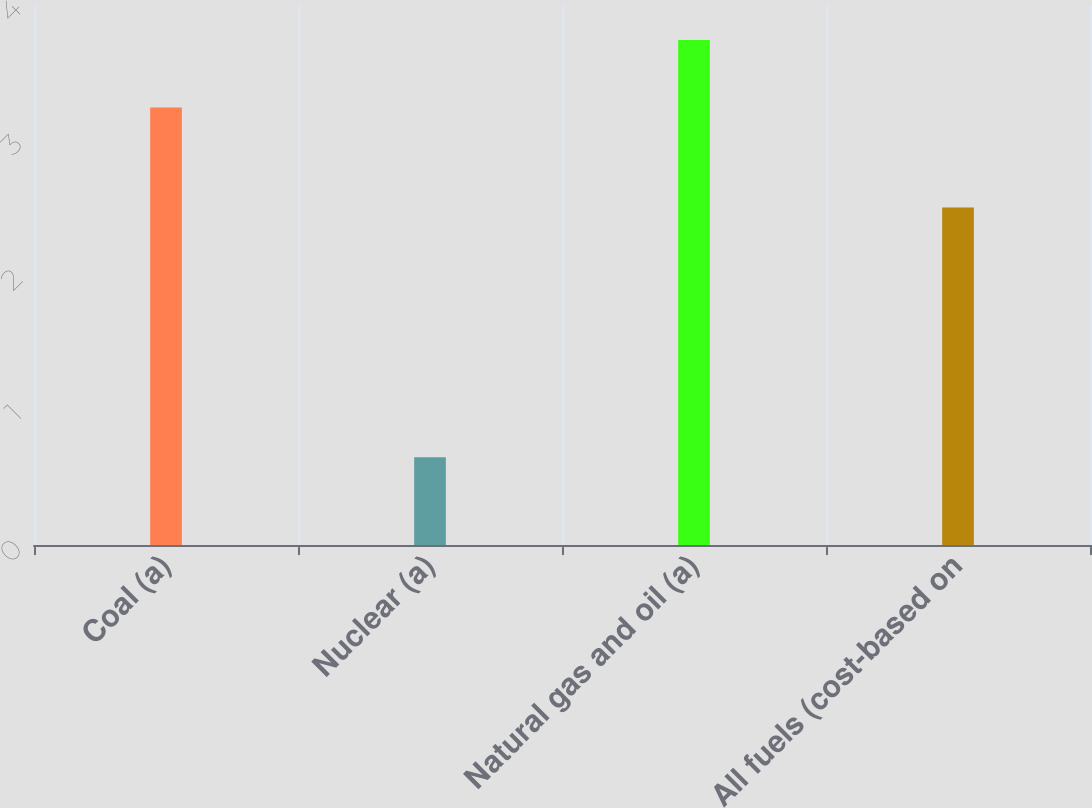<chart> <loc_0><loc_0><loc_500><loc_500><bar_chart><fcel>Coal (a)<fcel>Nuclear (a)<fcel>Natural gas and oil (a)<fcel>All fuels (cost-based on<nl><fcel>3.24<fcel>0.65<fcel>3.74<fcel>2.5<nl></chart> 